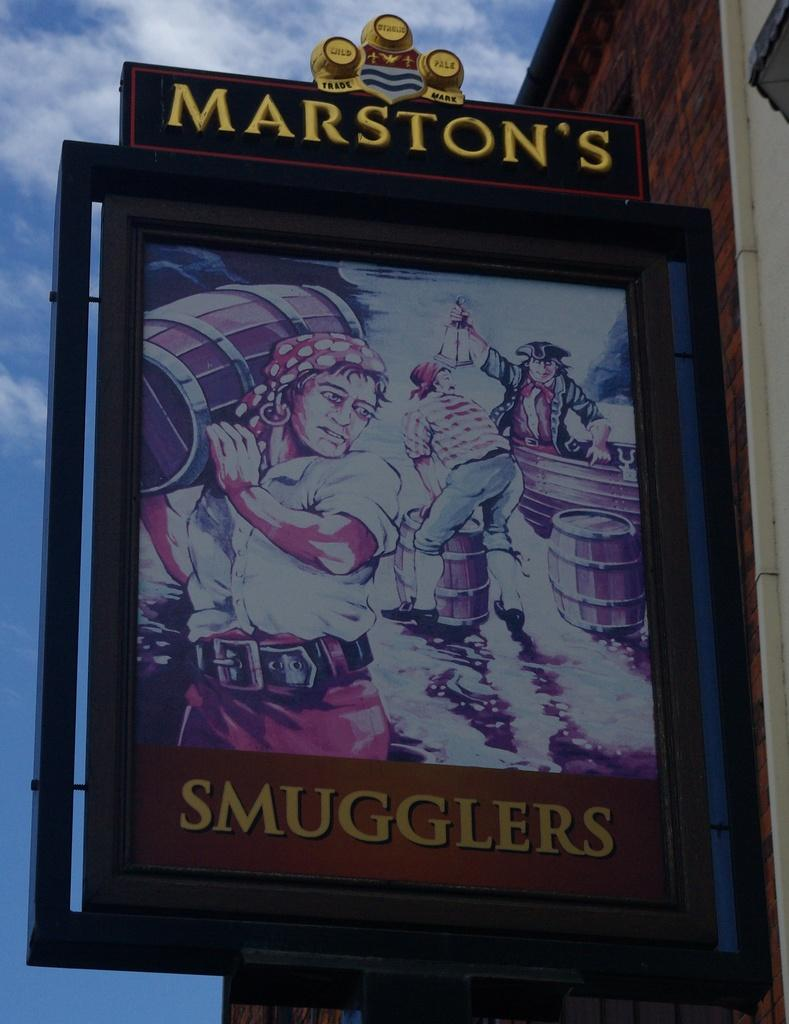<image>
Write a terse but informative summary of the picture. A large sign shows an advertisement for Marston's. 